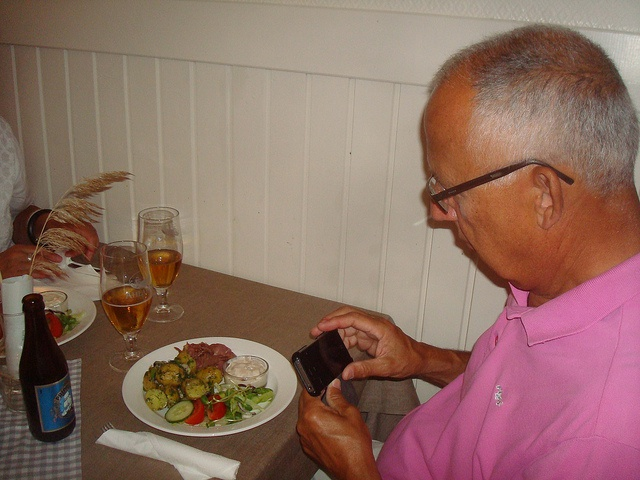Describe the objects in this image and their specific colors. I can see people in maroon, brown, and violet tones, dining table in maroon, black, and gray tones, people in maroon, gray, and black tones, bottle in maroon, black, darkblue, and gray tones, and wine glass in maroon and gray tones in this image. 